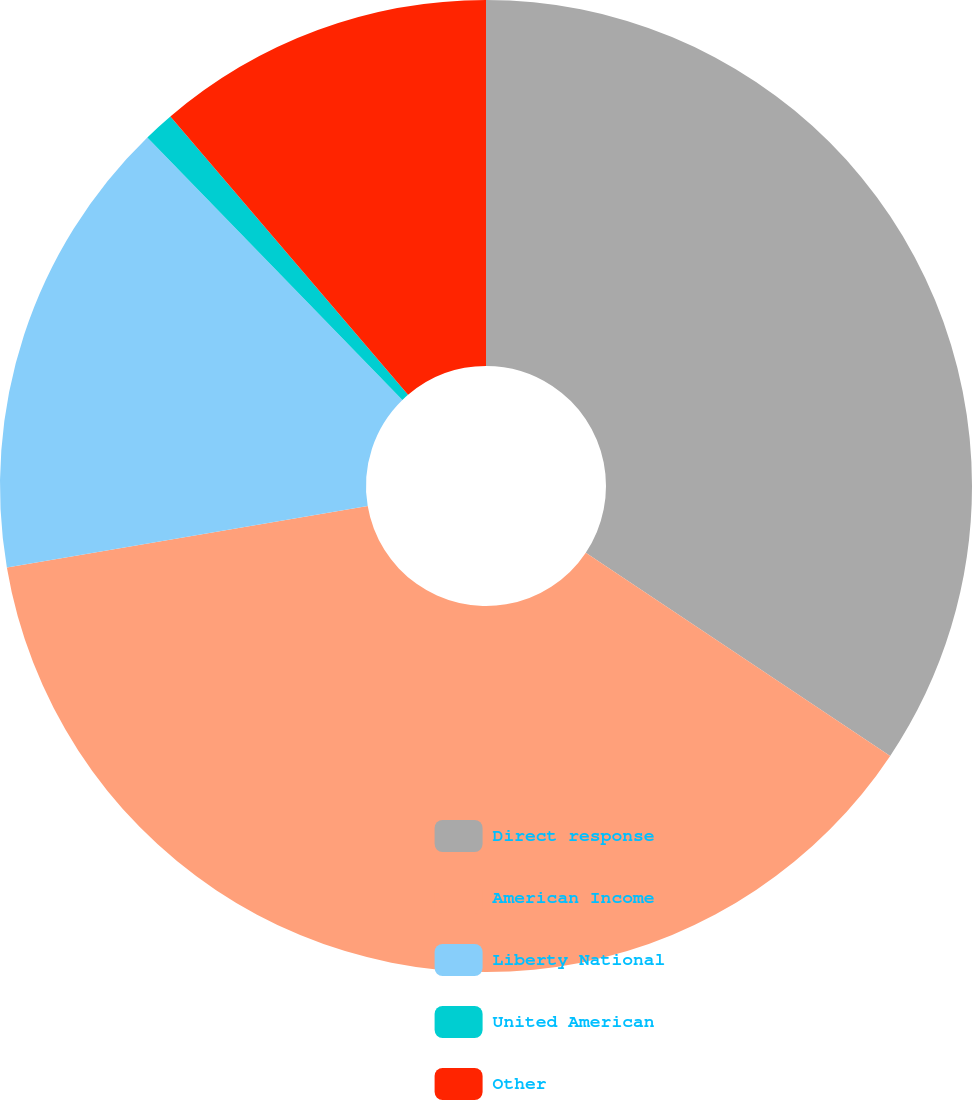Convert chart to OTSL. <chart><loc_0><loc_0><loc_500><loc_500><pie_chart><fcel>Direct response<fcel>American Income<fcel>Liberty National<fcel>United American<fcel>Other<nl><fcel>34.37%<fcel>37.95%<fcel>15.41%<fcel>1.02%<fcel>11.25%<nl></chart> 